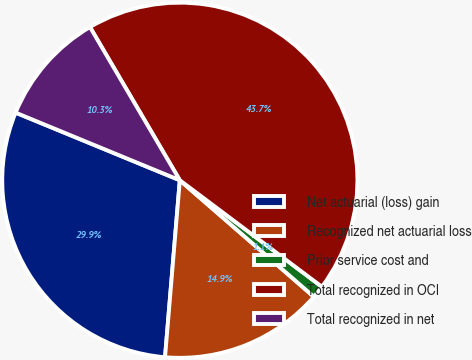Convert chart to OTSL. <chart><loc_0><loc_0><loc_500><loc_500><pie_chart><fcel>Net actuarial (loss) gain<fcel>Recognized net actuarial loss<fcel>Prior service cost and<fcel>Total recognized in OCI<fcel>Total recognized in net<nl><fcel>29.89%<fcel>14.94%<fcel>1.15%<fcel>43.68%<fcel>10.34%<nl></chart> 